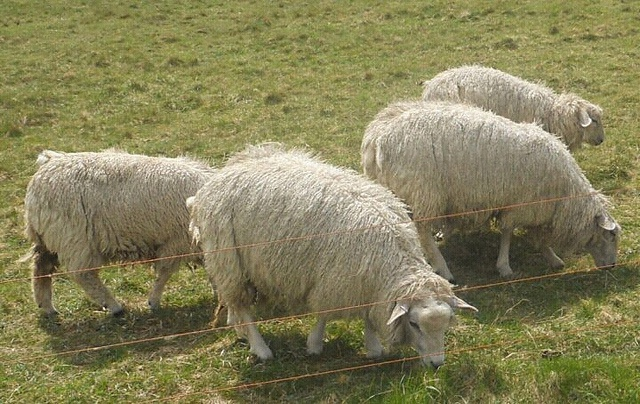Describe the objects in this image and their specific colors. I can see sheep in olive, gray, darkgray, and beige tones, sheep in olive, gray, and darkgray tones, sheep in olive and gray tones, and sheep in olive, darkgray, gray, and beige tones in this image. 